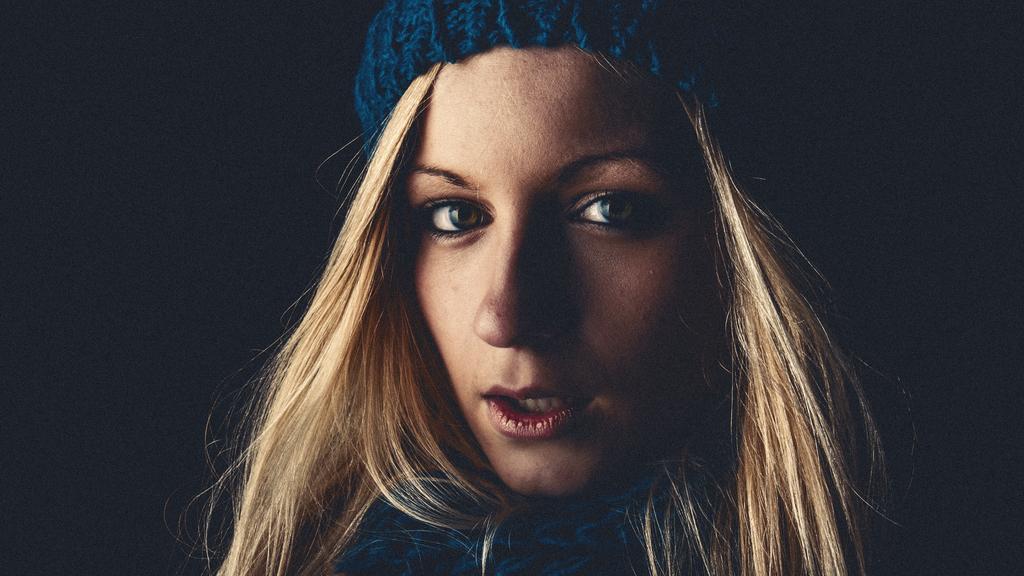In one or two sentences, can you explain what this image depicts? In this image I can see the person is wearing blue color dress. Background is in black color. 